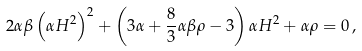Convert formula to latex. <formula><loc_0><loc_0><loc_500><loc_500>2 \alpha \beta \left ( \alpha H ^ { 2 } \right ) ^ { 2 } + \left ( 3 \alpha + \frac { 8 } { 3 } \alpha \beta \rho - 3 \right ) \alpha H ^ { 2 } + \alpha \rho = 0 \, ,</formula> 